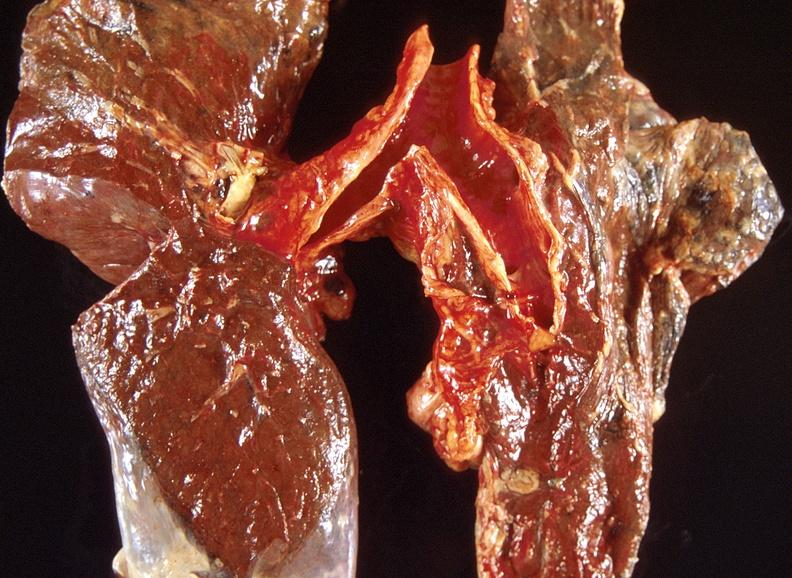where is this?
Answer the question using a single word or phrase. Lung 